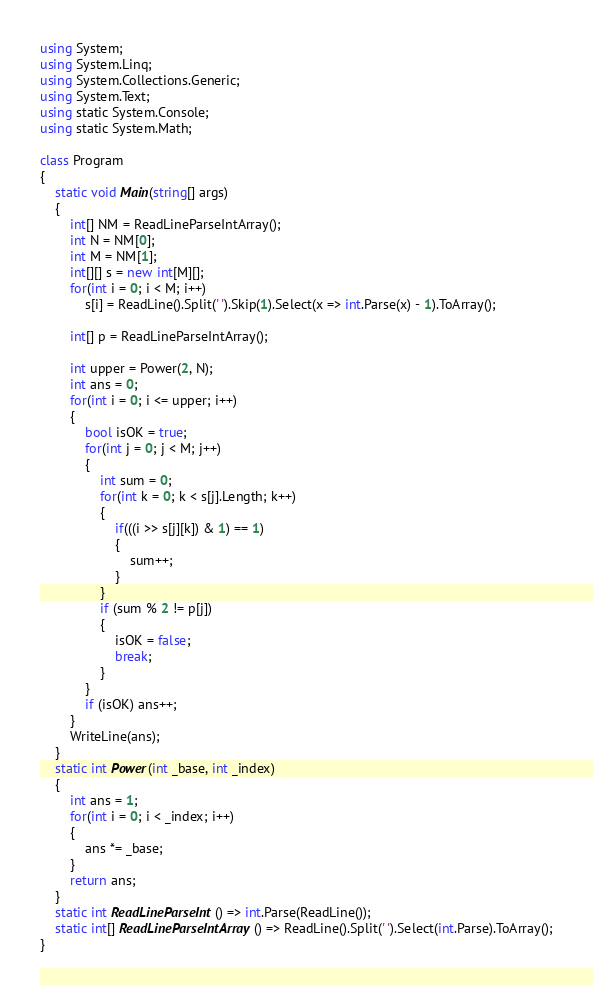Convert code to text. <code><loc_0><loc_0><loc_500><loc_500><_C#_>using System;
using System.Linq;
using System.Collections.Generic;
using System.Text;
using static System.Console;
using static System.Math;

class Program
{
    static void Main(string[] args)
    {
        int[] NM = ReadLineParseIntArray();
        int N = NM[0];
        int M = NM[1];
        int[][] s = new int[M][];
        for(int i = 0; i < M; i++)
            s[i] = ReadLine().Split(' ').Skip(1).Select(x => int.Parse(x) - 1).ToArray();

        int[] p = ReadLineParseIntArray();

        int upper = Power(2, N);
        int ans = 0;
        for(int i = 0; i <= upper; i++)
        {
            bool isOK = true;
            for(int j = 0; j < M; j++)
            {
                int sum = 0;
                for(int k = 0; k < s[j].Length; k++)
                {
                    if(((i >> s[j][k]) & 1) == 1)
                    {
                        sum++;
                    }
                }
                if (sum % 2 != p[j])
                {
                    isOK = false;
                    break;
                }
            }
            if (isOK) ans++;
        }
        WriteLine(ans);
    }
    static int Power(int _base, int _index)
    {
        int ans = 1;
        for(int i = 0; i < _index; i++)
        {
            ans *= _base;
        }
        return ans;
    }
    static int ReadLineParseInt() => int.Parse(ReadLine());
    static int[] ReadLineParseIntArray() => ReadLine().Split(' ').Select(int.Parse).ToArray();
}</code> 